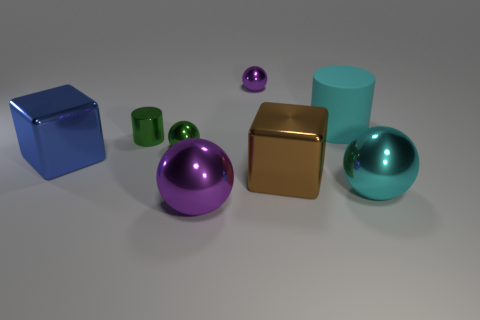What size is the cyan thing behind the metal block in front of the big blue object?
Offer a terse response. Large. What number of other objects are there of the same material as the small green sphere?
Make the answer very short. 6. Are there the same number of big cyan shiny things that are behind the large cyan metallic ball and cyan cylinders that are left of the tiny purple metallic sphere?
Keep it short and to the point. Yes. What number of cyan things have the same shape as the big blue shiny object?
Offer a terse response. 0. Is there a big cyan object made of the same material as the big purple object?
Keep it short and to the point. Yes. There is a tiny thing that is the same color as the metallic cylinder; what is its shape?
Keep it short and to the point. Sphere. How many rubber things are there?
Offer a terse response. 1. What number of cylinders are either large matte objects or tiny metal things?
Make the answer very short. 2. There is a cube that is the same size as the brown metallic thing; what color is it?
Ensure brevity in your answer.  Blue. What number of metallic spheres are in front of the rubber object and on the left side of the cyan sphere?
Offer a terse response. 2. 